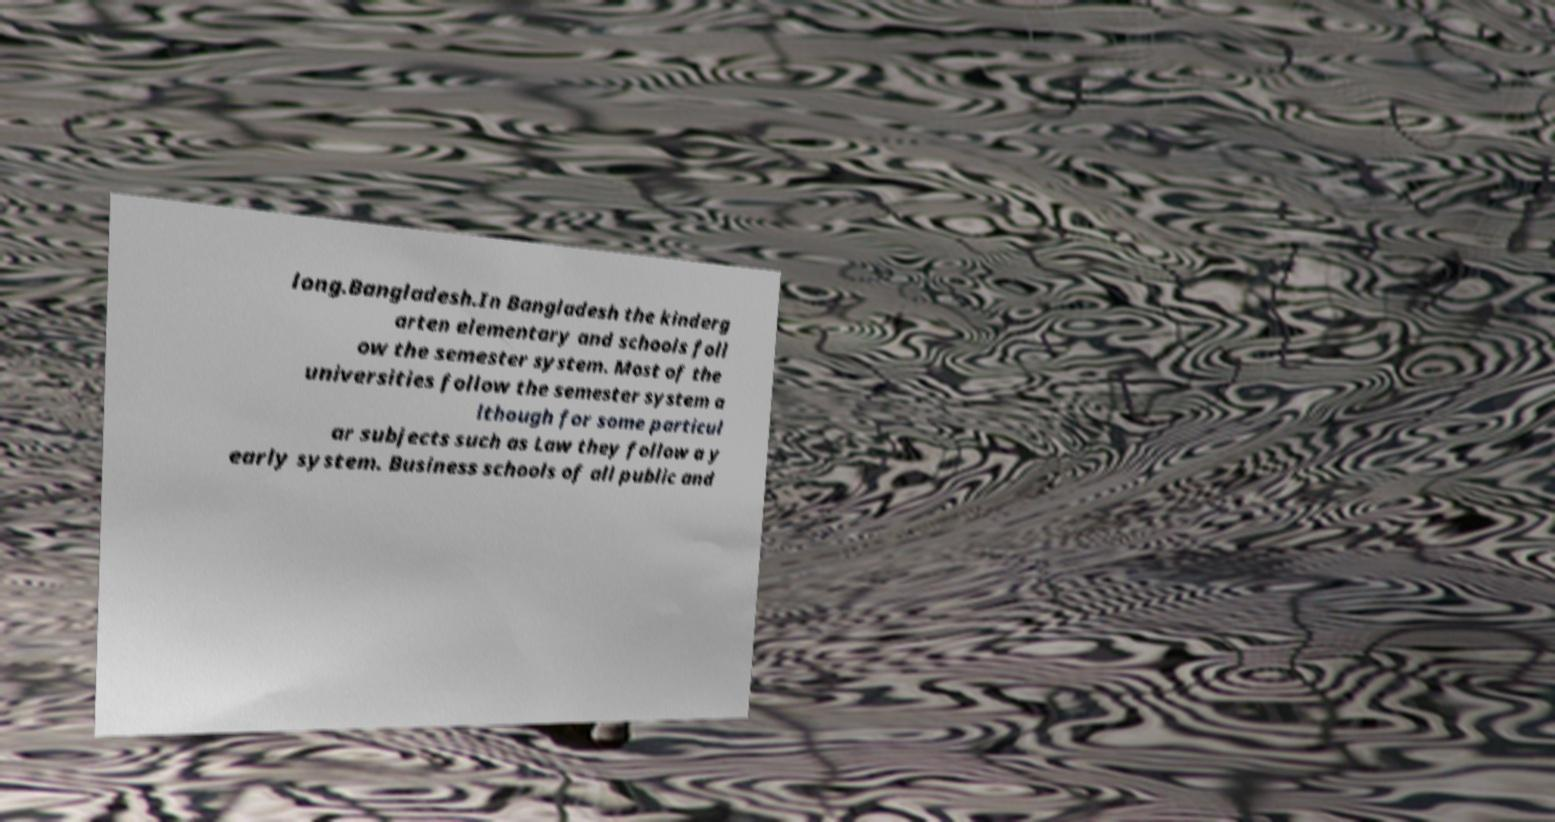Please read and relay the text visible in this image. What does it say? long.Bangladesh.In Bangladesh the kinderg arten elementary and schools foll ow the semester system. Most of the universities follow the semester system a lthough for some particul ar subjects such as Law they follow a y early system. Business schools of all public and 